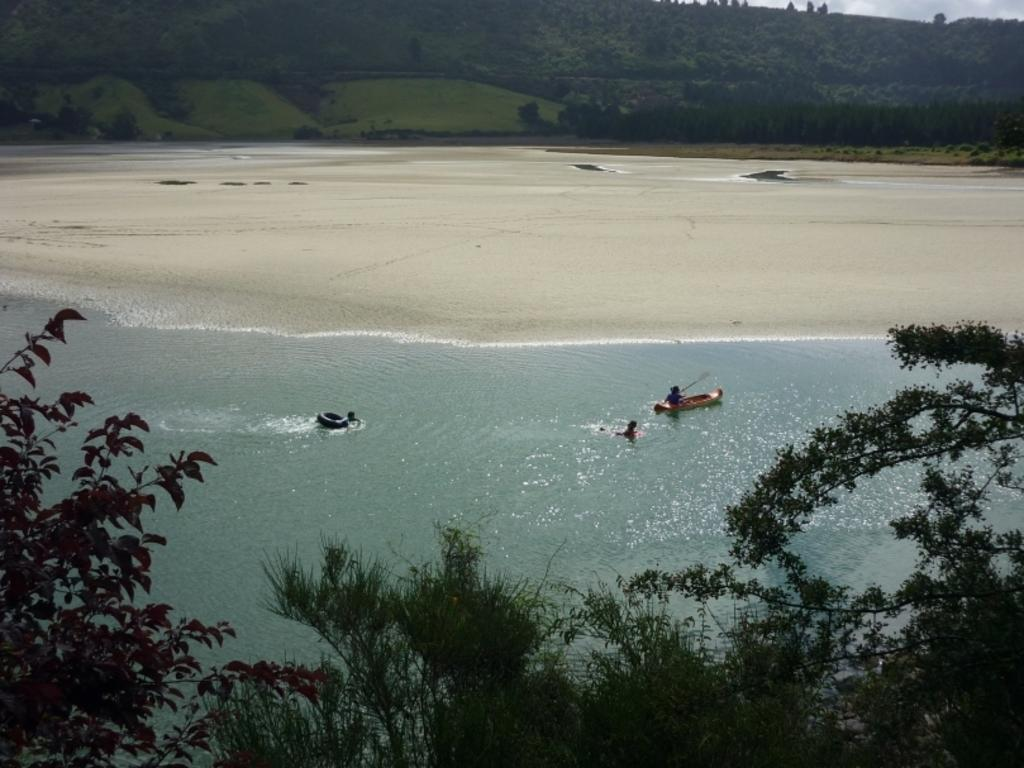What is the main subject of the image? The main subject of the image is a boat. Are there any people present in the image? Yes, there are people in the image. What type of environment is depicted in the image? The image features water, trees, and mountains. What type of bun is being used as a prop in the image? There is no bun present in the image. Can you tell me how many rifles are visible in the image? There are no rifles visible in the image. 